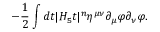<formula> <loc_0><loc_0><loc_500><loc_500>- { \frac { 1 } { 2 } } \int d t | H _ { 5 } t | ^ { n } \eta ^ { \mu \nu } \partial _ { \mu } \varphi \partial _ { \nu } \varphi .</formula> 